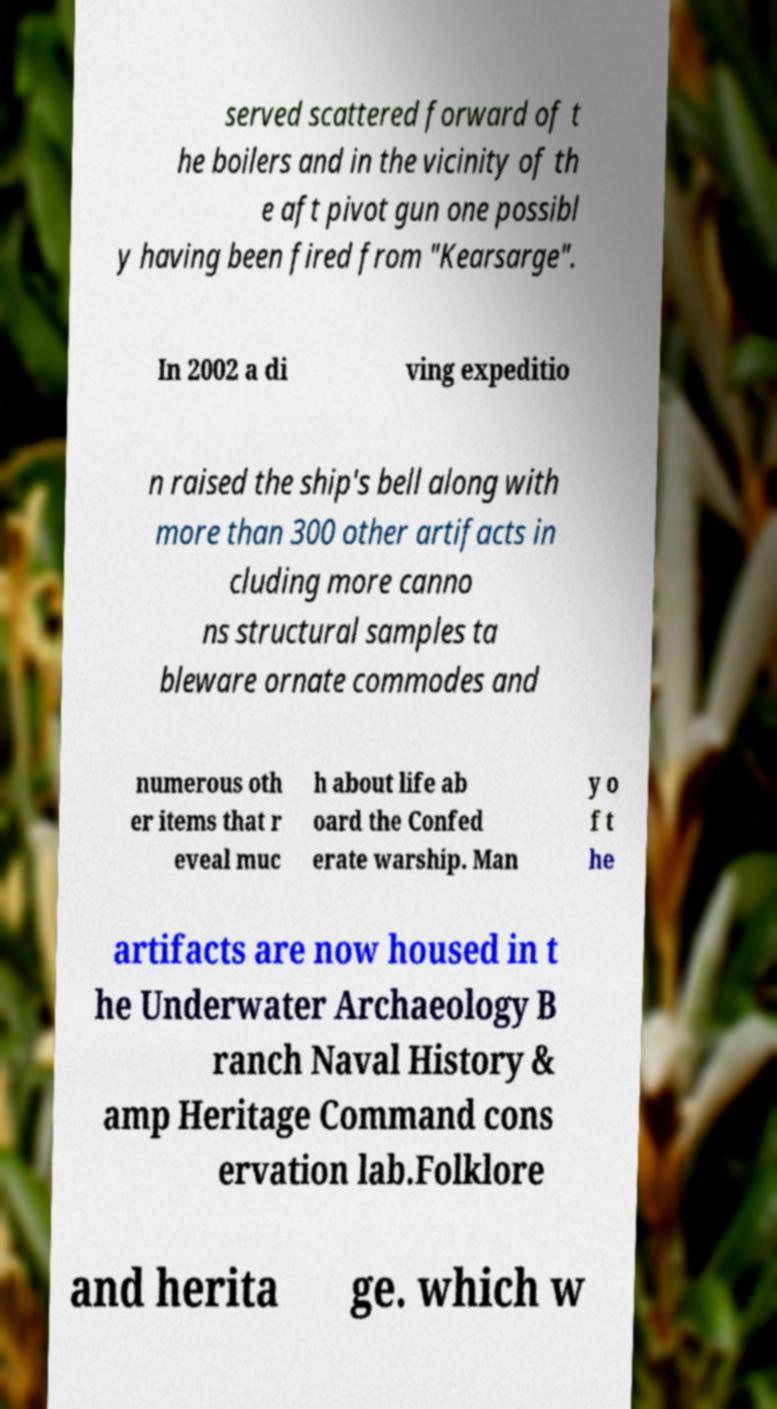Could you extract and type out the text from this image? served scattered forward of t he boilers and in the vicinity of th e aft pivot gun one possibl y having been fired from "Kearsarge". In 2002 a di ving expeditio n raised the ship's bell along with more than 300 other artifacts in cluding more canno ns structural samples ta bleware ornate commodes and numerous oth er items that r eveal muc h about life ab oard the Confed erate warship. Man y o f t he artifacts are now housed in t he Underwater Archaeology B ranch Naval History & amp Heritage Command cons ervation lab.Folklore and herita ge. which w 